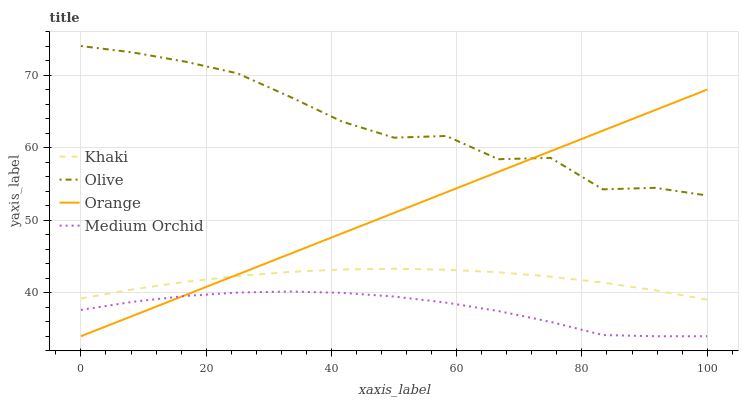Does Medium Orchid have the minimum area under the curve?
Answer yes or no. Yes. Does Olive have the maximum area under the curve?
Answer yes or no. Yes. Does Orange have the minimum area under the curve?
Answer yes or no. No. Does Orange have the maximum area under the curve?
Answer yes or no. No. Is Orange the smoothest?
Answer yes or no. Yes. Is Olive the roughest?
Answer yes or no. Yes. Is Medium Orchid the smoothest?
Answer yes or no. No. Is Medium Orchid the roughest?
Answer yes or no. No. Does Orange have the lowest value?
Answer yes or no. Yes. Does Khaki have the lowest value?
Answer yes or no. No. Does Olive have the highest value?
Answer yes or no. Yes. Does Orange have the highest value?
Answer yes or no. No. Is Medium Orchid less than Olive?
Answer yes or no. Yes. Is Olive greater than Khaki?
Answer yes or no. Yes. Does Orange intersect Olive?
Answer yes or no. Yes. Is Orange less than Olive?
Answer yes or no. No. Is Orange greater than Olive?
Answer yes or no. No. Does Medium Orchid intersect Olive?
Answer yes or no. No. 